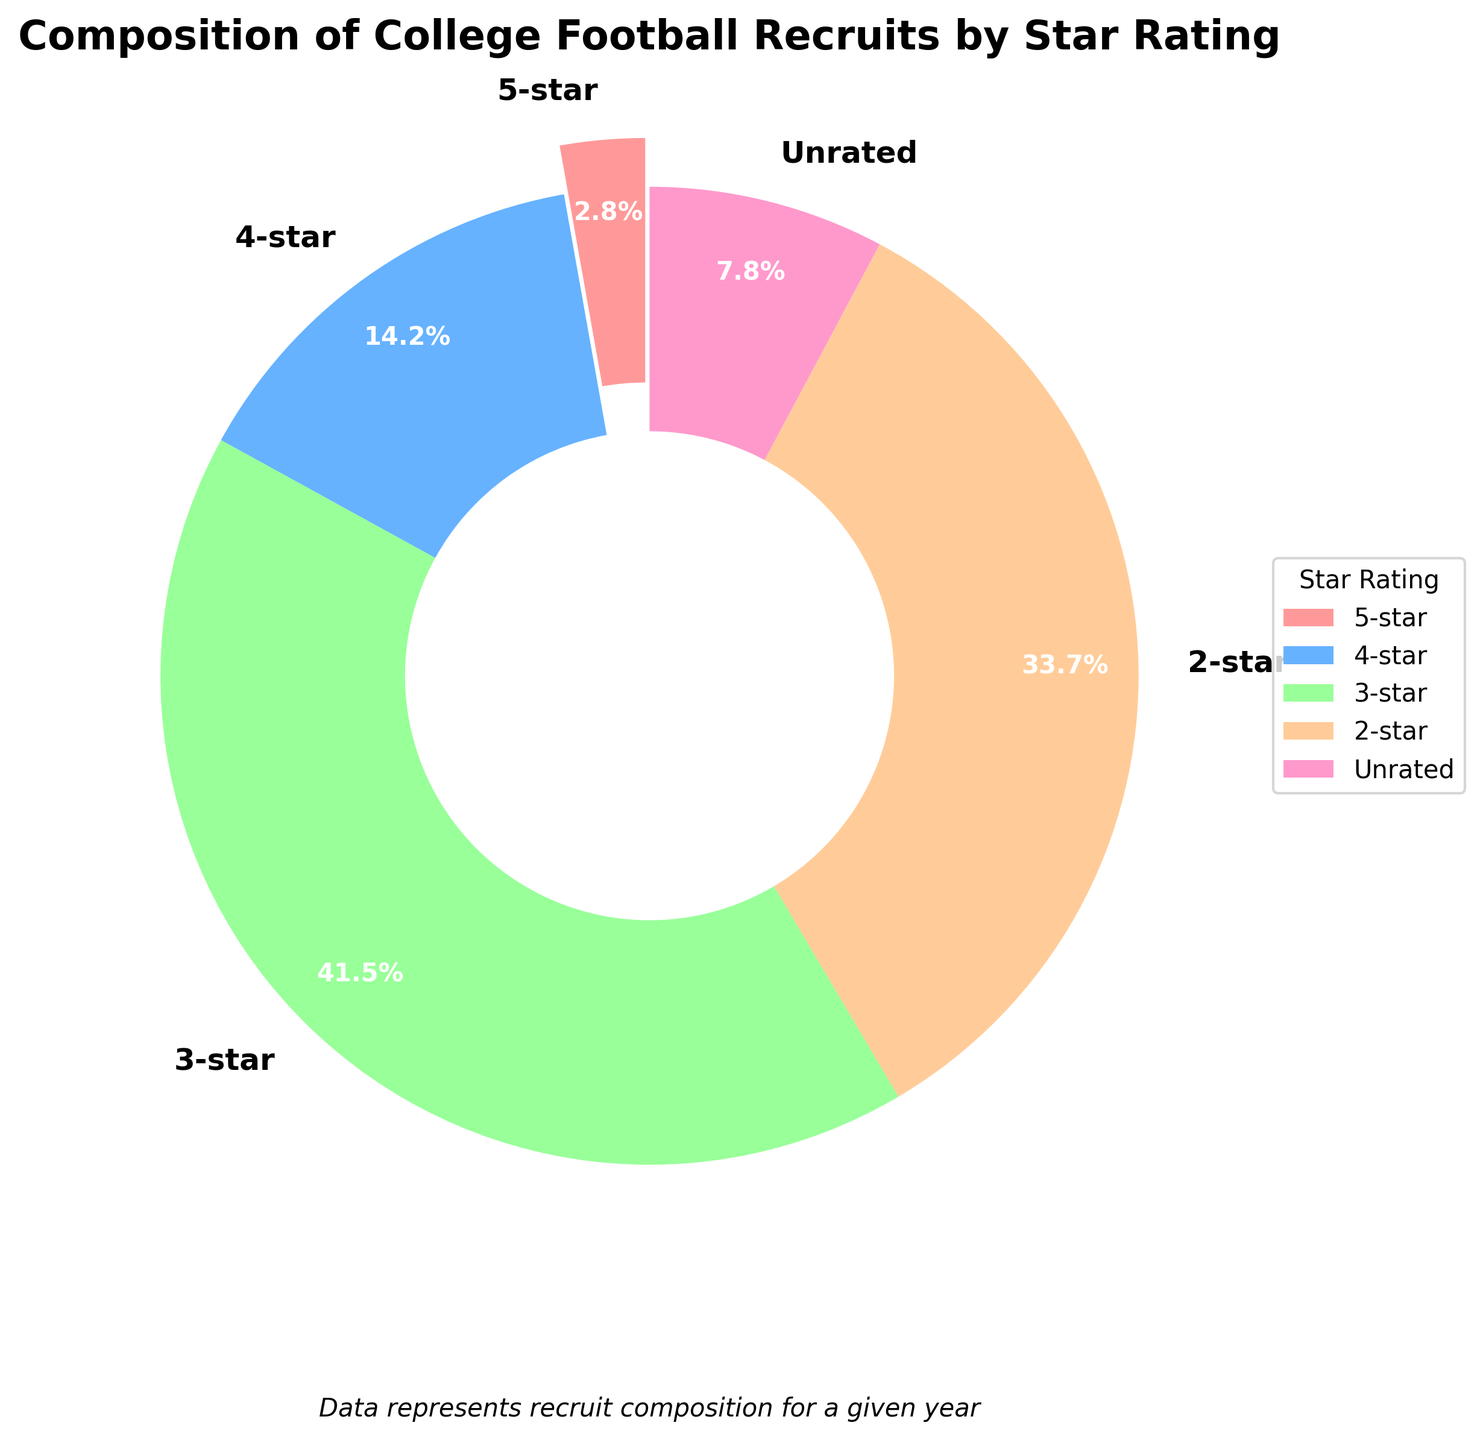which star rating represents the smallest proportion of recruits? Look at the pie chart wedges and note the star rating with the smallest percentage. The 5-star rating has the smallest percentage of 2.8%.
Answer: 5-star Which two star ratings together make up more than 70% of the recruits? Sum up the percentages of different star ratings to find the ones that together exceed 70%. The 3-star and 2-star ratings together make up 41.5% + 33.7% = 75.2%.
Answer: 3-star and 2-star What is the total percentage of recruits that are either 4-star or above? Add the percentages of the 5-star and 4-star categories. 5-star is 2.8% and 4-star is 14.2%; therefore, the total is 2.8% + 14.2% = 17.0%.
Answer: 17.0% Is the percentage of 2-star recruits greater or lesser than 3-star recruits? Compare the percentages of 2-star (33.7%) and 3-star (41.5%) recruits. 2-star is lesser than 3-star.
Answer: Lesser Which star rating is represented by the blue color in the pie chart? Identify the blue segment of the pie chart; according to the provided color scheme, blue represents the 4-star rating.
Answer: 4-star What is the combined percentage of 5-star and 4-star recruits? Add the percentages of 5-star and 4-star categories. 2.8% (5-star) + 14.2% (4-star) = 17.0%.
Answer: 17.0% Which rating has a larger proportion, 2-star or unrated recruits? Compare the percentages of 2-star (33.7%) and unrated (7.8%). 2-star is larger.
Answer: 2-star How much greater is the percentage of 3-star recruits compared to 4-star recruits? Subtract the percentage of 4-star recruits from 3-star recruits. 41.5% - 14.2% = 27.3%.
Answer: 27.3% What proportion of recruits are rated 4-star or below? Add the percentages of 4-star, 3-star, 2-star, and unrated recruits. 14.2% + 41.5% + 33.7% + 7.8% = 97.2%.
Answer: 97.2% 